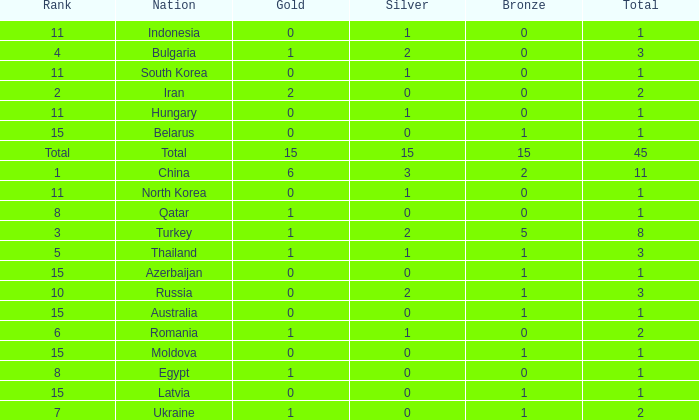What is the sum of the bronze medals of the nation with less than 0 silvers? None. I'm looking to parse the entire table for insights. Could you assist me with that? {'header': ['Rank', 'Nation', 'Gold', 'Silver', 'Bronze', 'Total'], 'rows': [['11', 'Indonesia', '0', '1', '0', '1'], ['4', 'Bulgaria', '1', '2', '0', '3'], ['11', 'South Korea', '0', '1', '0', '1'], ['2', 'Iran', '2', '0', '0', '2'], ['11', 'Hungary', '0', '1', '0', '1'], ['15', 'Belarus', '0', '0', '1', '1'], ['Total', 'Total', '15', '15', '15', '45'], ['1', 'China', '6', '3', '2', '11'], ['11', 'North Korea', '0', '1', '0', '1'], ['8', 'Qatar', '1', '0', '0', '1'], ['3', 'Turkey', '1', '2', '5', '8'], ['5', 'Thailand', '1', '1', '1', '3'], ['15', 'Azerbaijan', '0', '0', '1', '1'], ['10', 'Russia', '0', '2', '1', '3'], ['15', 'Australia', '0', '0', '1', '1'], ['6', 'Romania', '1', '1', '0', '2'], ['15', 'Moldova', '0', '0', '1', '1'], ['8', 'Egypt', '1', '0', '0', '1'], ['15', 'Latvia', '0', '0', '1', '1'], ['7', 'Ukraine', '1', '0', '1', '2']]} 